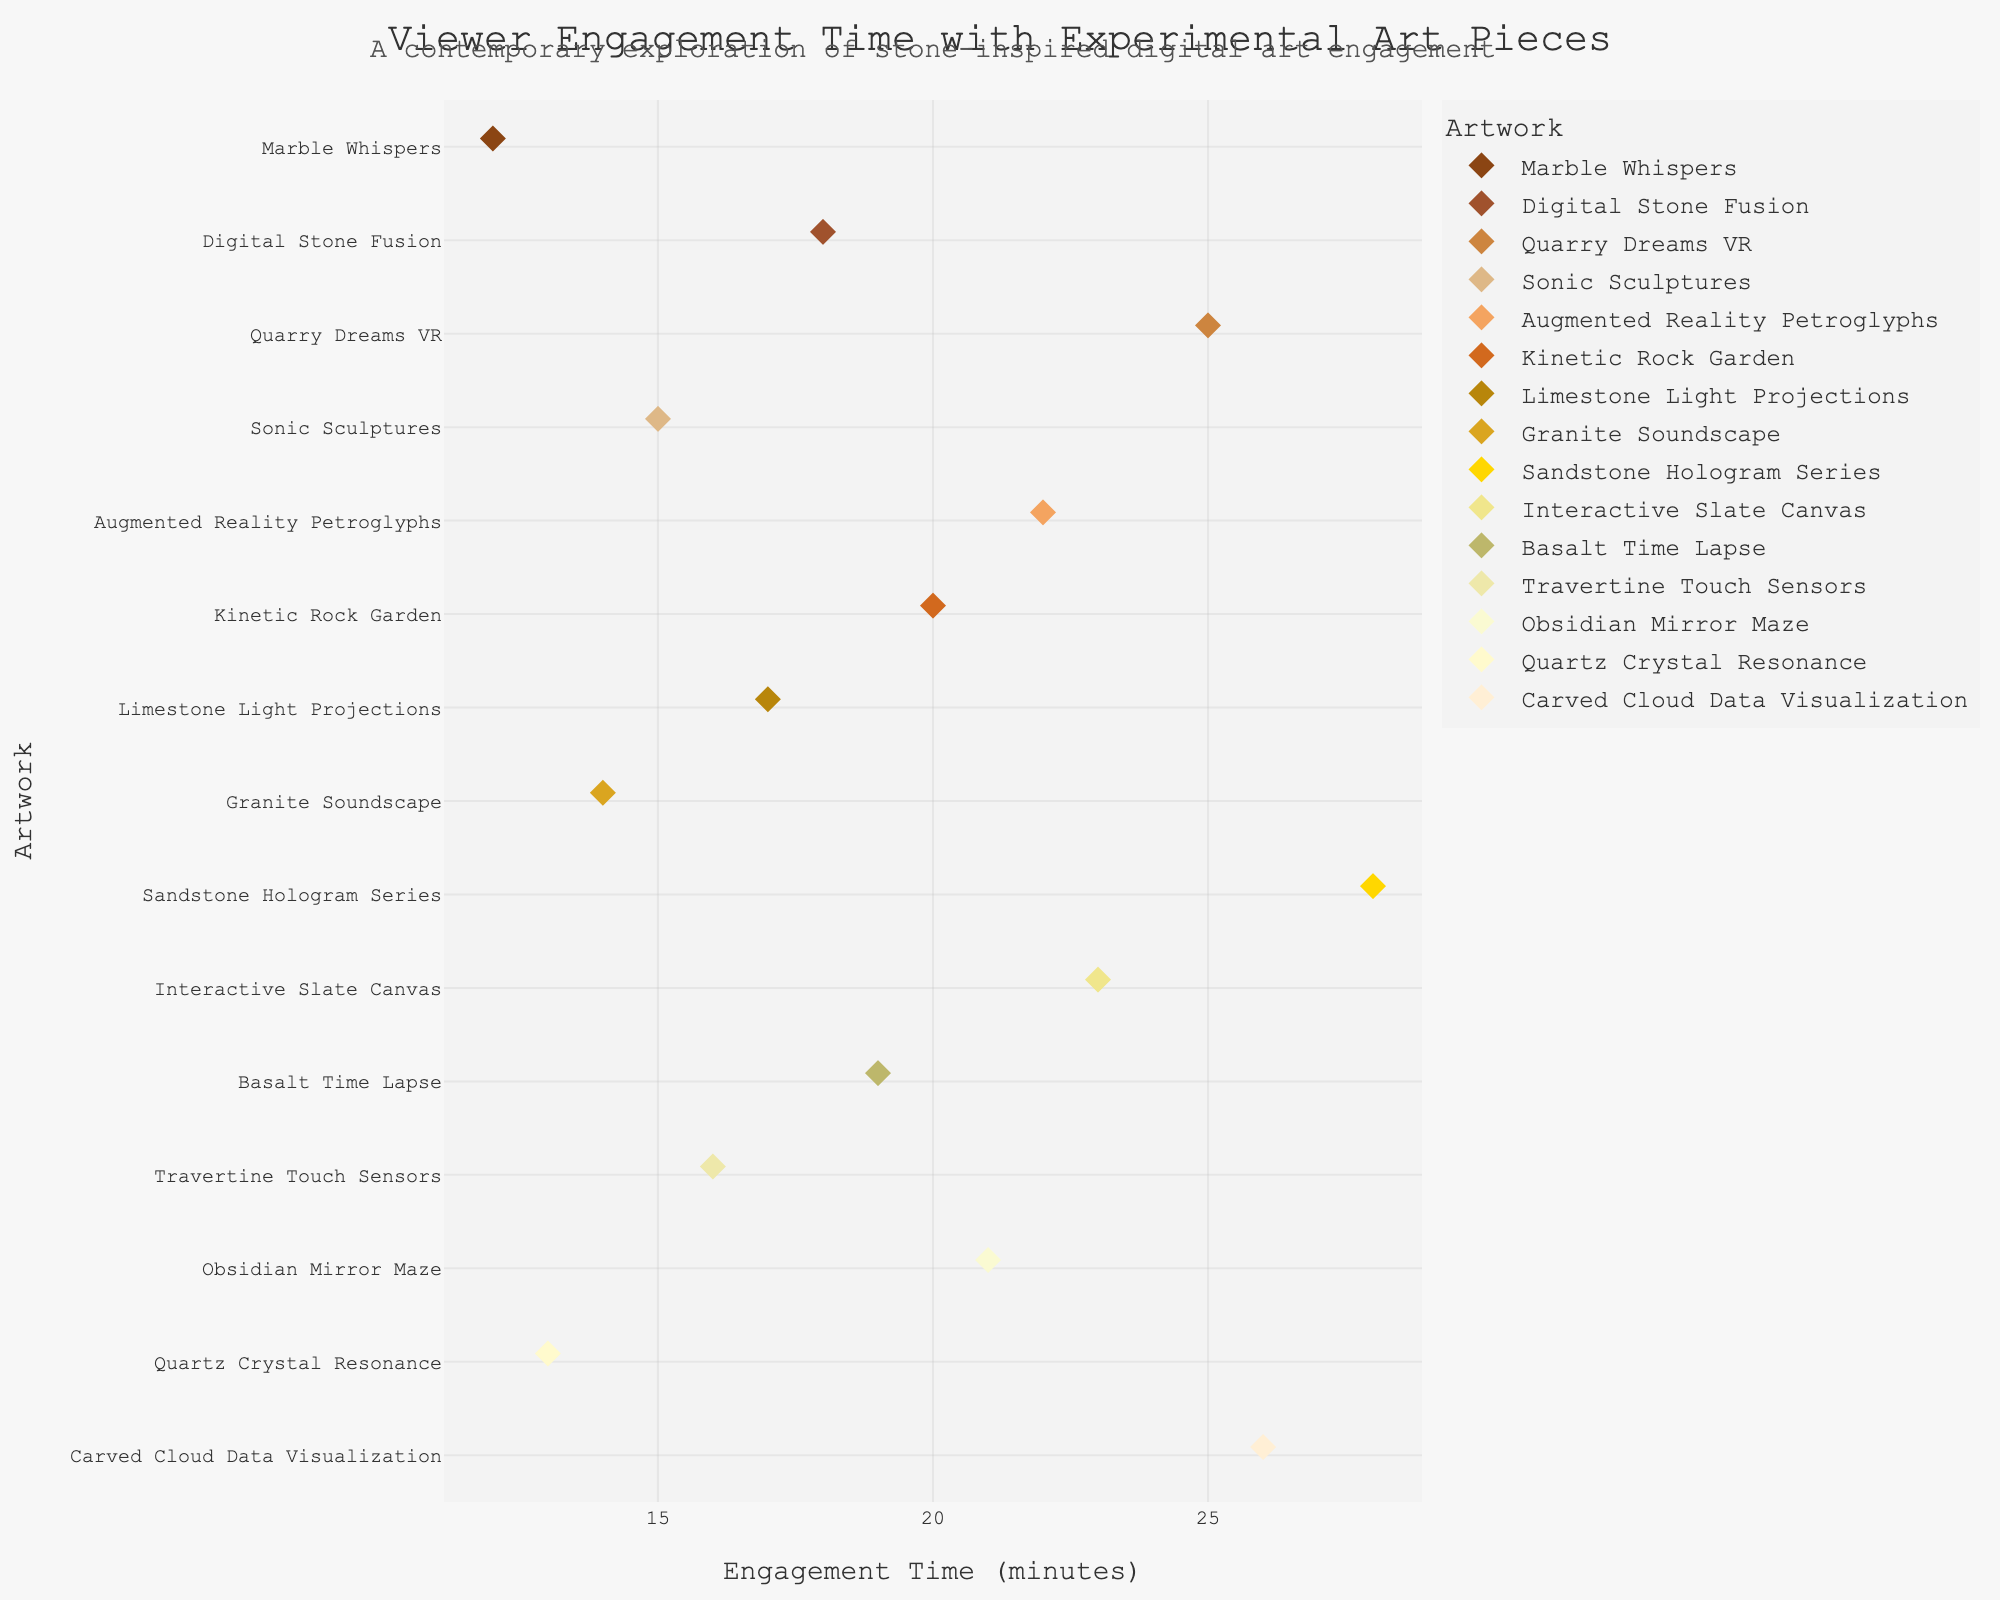how many experimental art pieces are displayed in the plot? There are multiple data points grouped by each art piece on the y-axis. Counting these groups reveals the total number of different art pieces. In this case, there are 15 groups.
Answer: 15 which artwork has the highest viewer engagement time? To find the artwork with the highest engagement time, look at the x-axis values for each group and identify the one with the highest value. "Sandstone Hologram Series" has the highest engagement time of 28 minutes.
Answer: Sandstone Hologram Series what is the average engagement time for all artworks? Sum all the engagement times and divide by the number of artworks. Summing the engagement times: (12 + 18 + 25 + 15 + 22 + 20 + 17 + 14 + 28 + 23 + 19 + 16 + 21 + 13 + 26) = 289. Dividing by the number of artworks: 289 / 15 ≈ 19.27.
Answer: 19.27 minutes which artwork has the closest engagement time to the median value? First, find the median engagement time by listing all engagement times in ascending order and finding the middle value. Sorted times: (12, 13, 14, 15, 16, 17, 18, 19, 20, 21, 22, 23, 25, 26, 28). The median is the 8th value, which is 19. The artwork closest to this time is "Basalt Time Lapse" with exactly 19 minutes.
Answer: Basalt Time Lapse compare the engagement times of "Marble Whispers" and "Quartz Crystal Resonance" and state which one has higher engagement Locate the engagement times for both artworks. "Marble Whispers" has 12 minutes, while "Quartz Crystal Resonance" has 13 minutes. 13 > 12, so "Quartz Crystal Resonance" has higher engagement.
Answer: Quartz Crystal Resonance what is the range of engagement times across all artworks? The range is found by subtracting the minimum engagement time from the maximum engagement time. The minimum is 12 minutes from "Marble Whispers" and the maximum is 28 minutes from "Sandstone Hologram Series". The range is 28 - 12 = 16 minutes.
Answer: 16 minutes which artwork has the lowest viewer engagement time, and how much lower is it compared to the highest engagement time? Identify the artworks with the lowest and highest engagement times. "Marble Whispers" has the lowest at 12 minutes, and "Sandstone Hologram Series" has the highest at 28 minutes. The difference is 28 - 12 = 16 minutes.
Answer: Marble Whispers, 16 minutes what is the difference in engagement time between "Kinetic Rock Garden" and "Interactive Slate Canvas"? Kinetic Rock Garden has an engagement time of 20 minutes, while Interactive Slate Canvas has 23 minutes. The difference is 23 - 20 = 3 minutes.
Answer: 3 minutes how many artworks have an engagement time of 20 minutes or more? Count the artworks with engagement times of 20 minutes or more. These are "Digital Stone Fusion" (18 excluded), "Quarry Dreams VR", "Augmented Reality Petroglyphs", "Kinetic Rock Garden", "Sandstone Hologram Series", "Interactive Slate Canvas", "Basalt Time Lapse", "Obsidian Mirror Maze", and "Carved Cloud Data Visualization". This results in 9 artworks.
Answer: 9 